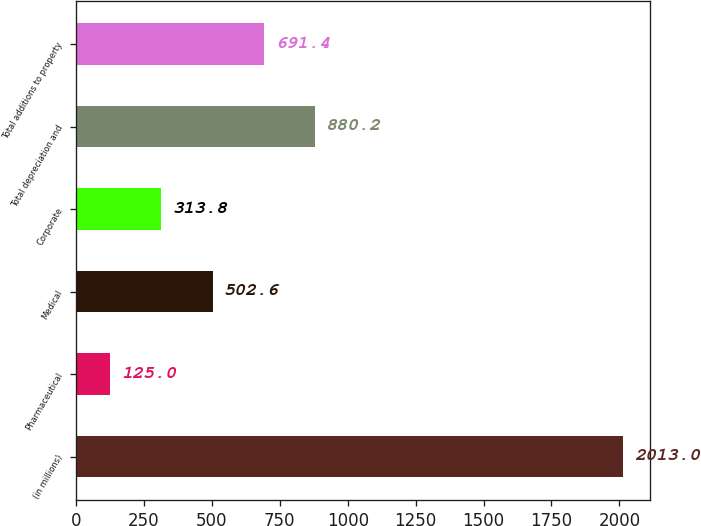<chart> <loc_0><loc_0><loc_500><loc_500><bar_chart><fcel>(in millions)<fcel>Pharmaceutical<fcel>Medical<fcel>Corporate<fcel>Total depreciation and<fcel>Total additions to property<nl><fcel>2013<fcel>125<fcel>502.6<fcel>313.8<fcel>880.2<fcel>691.4<nl></chart> 